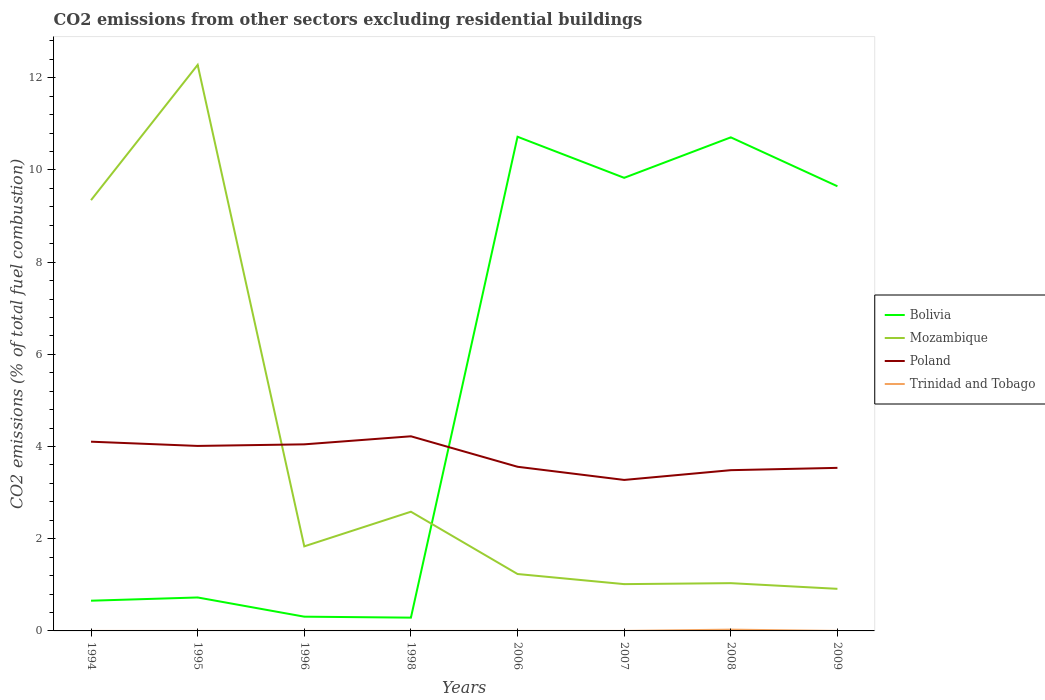How many different coloured lines are there?
Provide a succinct answer. 4. Does the line corresponding to Trinidad and Tobago intersect with the line corresponding to Poland?
Keep it short and to the point. No. Is the number of lines equal to the number of legend labels?
Keep it short and to the point. No. Across all years, what is the maximum total CO2 emitted in Poland?
Give a very brief answer. 3.28. What is the total total CO2 emitted in Poland in the graph?
Provide a succinct answer. 0.51. What is the difference between the highest and the second highest total CO2 emitted in Poland?
Your answer should be very brief. 0.95. What is the difference between the highest and the lowest total CO2 emitted in Bolivia?
Provide a succinct answer. 4. How many lines are there?
Your answer should be compact. 4. How many years are there in the graph?
Keep it short and to the point. 8. Are the values on the major ticks of Y-axis written in scientific E-notation?
Provide a short and direct response. No. Does the graph contain any zero values?
Provide a succinct answer. Yes. Where does the legend appear in the graph?
Make the answer very short. Center right. How many legend labels are there?
Offer a terse response. 4. What is the title of the graph?
Ensure brevity in your answer.  CO2 emissions from other sectors excluding residential buildings. Does "Peru" appear as one of the legend labels in the graph?
Offer a terse response. No. What is the label or title of the Y-axis?
Offer a terse response. CO2 emissions (% of total fuel combustion). What is the CO2 emissions (% of total fuel combustion) in Bolivia in 1994?
Your answer should be very brief. 0.66. What is the CO2 emissions (% of total fuel combustion) of Mozambique in 1994?
Your answer should be very brief. 9.35. What is the CO2 emissions (% of total fuel combustion) in Poland in 1994?
Your answer should be very brief. 4.11. What is the CO2 emissions (% of total fuel combustion) in Trinidad and Tobago in 1994?
Keep it short and to the point. 0. What is the CO2 emissions (% of total fuel combustion) in Bolivia in 1995?
Offer a terse response. 0.73. What is the CO2 emissions (% of total fuel combustion) of Mozambique in 1995?
Give a very brief answer. 12.28. What is the CO2 emissions (% of total fuel combustion) in Poland in 1995?
Offer a very short reply. 4.01. What is the CO2 emissions (% of total fuel combustion) in Trinidad and Tobago in 1995?
Provide a succinct answer. 0. What is the CO2 emissions (% of total fuel combustion) in Bolivia in 1996?
Your answer should be compact. 0.31. What is the CO2 emissions (% of total fuel combustion) of Mozambique in 1996?
Give a very brief answer. 1.83. What is the CO2 emissions (% of total fuel combustion) of Poland in 1996?
Keep it short and to the point. 4.05. What is the CO2 emissions (% of total fuel combustion) of Bolivia in 1998?
Make the answer very short. 0.29. What is the CO2 emissions (% of total fuel combustion) of Mozambique in 1998?
Offer a very short reply. 2.59. What is the CO2 emissions (% of total fuel combustion) of Poland in 1998?
Provide a short and direct response. 4.22. What is the CO2 emissions (% of total fuel combustion) of Bolivia in 2006?
Provide a short and direct response. 10.72. What is the CO2 emissions (% of total fuel combustion) of Mozambique in 2006?
Offer a terse response. 1.23. What is the CO2 emissions (% of total fuel combustion) of Poland in 2006?
Keep it short and to the point. 3.56. What is the CO2 emissions (% of total fuel combustion) in Trinidad and Tobago in 2006?
Keep it short and to the point. 5.05750284541343e-17. What is the CO2 emissions (% of total fuel combustion) of Bolivia in 2007?
Your answer should be compact. 9.83. What is the CO2 emissions (% of total fuel combustion) in Mozambique in 2007?
Offer a very short reply. 1.02. What is the CO2 emissions (% of total fuel combustion) in Poland in 2007?
Offer a terse response. 3.28. What is the CO2 emissions (% of total fuel combustion) in Trinidad and Tobago in 2007?
Offer a very short reply. 4.75396951487204e-17. What is the CO2 emissions (% of total fuel combustion) of Bolivia in 2008?
Provide a succinct answer. 10.71. What is the CO2 emissions (% of total fuel combustion) of Mozambique in 2008?
Your answer should be very brief. 1.04. What is the CO2 emissions (% of total fuel combustion) of Poland in 2008?
Your answer should be compact. 3.49. What is the CO2 emissions (% of total fuel combustion) of Trinidad and Tobago in 2008?
Your answer should be very brief. 0.03. What is the CO2 emissions (% of total fuel combustion) in Bolivia in 2009?
Offer a very short reply. 9.65. What is the CO2 emissions (% of total fuel combustion) of Mozambique in 2009?
Ensure brevity in your answer.  0.91. What is the CO2 emissions (% of total fuel combustion) of Poland in 2009?
Make the answer very short. 3.54. Across all years, what is the maximum CO2 emissions (% of total fuel combustion) in Bolivia?
Provide a succinct answer. 10.72. Across all years, what is the maximum CO2 emissions (% of total fuel combustion) in Mozambique?
Keep it short and to the point. 12.28. Across all years, what is the maximum CO2 emissions (% of total fuel combustion) in Poland?
Give a very brief answer. 4.22. Across all years, what is the maximum CO2 emissions (% of total fuel combustion) in Trinidad and Tobago?
Make the answer very short. 0.03. Across all years, what is the minimum CO2 emissions (% of total fuel combustion) of Bolivia?
Your answer should be compact. 0.29. Across all years, what is the minimum CO2 emissions (% of total fuel combustion) in Mozambique?
Provide a succinct answer. 0.91. Across all years, what is the minimum CO2 emissions (% of total fuel combustion) in Poland?
Your answer should be very brief. 3.28. Across all years, what is the minimum CO2 emissions (% of total fuel combustion) of Trinidad and Tobago?
Your response must be concise. 0. What is the total CO2 emissions (% of total fuel combustion) of Bolivia in the graph?
Your answer should be compact. 42.89. What is the total CO2 emissions (% of total fuel combustion) in Mozambique in the graph?
Ensure brevity in your answer.  30.25. What is the total CO2 emissions (% of total fuel combustion) in Poland in the graph?
Make the answer very short. 30.25. What is the total CO2 emissions (% of total fuel combustion) of Trinidad and Tobago in the graph?
Keep it short and to the point. 0.03. What is the difference between the CO2 emissions (% of total fuel combustion) of Bolivia in 1994 and that in 1995?
Your response must be concise. -0.07. What is the difference between the CO2 emissions (% of total fuel combustion) in Mozambique in 1994 and that in 1995?
Your answer should be very brief. -2.93. What is the difference between the CO2 emissions (% of total fuel combustion) of Poland in 1994 and that in 1995?
Offer a terse response. 0.09. What is the difference between the CO2 emissions (% of total fuel combustion) of Bolivia in 1994 and that in 1996?
Ensure brevity in your answer.  0.35. What is the difference between the CO2 emissions (% of total fuel combustion) in Mozambique in 1994 and that in 1996?
Keep it short and to the point. 7.51. What is the difference between the CO2 emissions (% of total fuel combustion) in Poland in 1994 and that in 1996?
Provide a short and direct response. 0.06. What is the difference between the CO2 emissions (% of total fuel combustion) in Bolivia in 1994 and that in 1998?
Make the answer very short. 0.37. What is the difference between the CO2 emissions (% of total fuel combustion) in Mozambique in 1994 and that in 1998?
Make the answer very short. 6.76. What is the difference between the CO2 emissions (% of total fuel combustion) in Poland in 1994 and that in 1998?
Offer a very short reply. -0.12. What is the difference between the CO2 emissions (% of total fuel combustion) in Bolivia in 1994 and that in 2006?
Ensure brevity in your answer.  -10.07. What is the difference between the CO2 emissions (% of total fuel combustion) of Mozambique in 1994 and that in 2006?
Your response must be concise. 8.11. What is the difference between the CO2 emissions (% of total fuel combustion) of Poland in 1994 and that in 2006?
Provide a short and direct response. 0.54. What is the difference between the CO2 emissions (% of total fuel combustion) of Bolivia in 1994 and that in 2007?
Give a very brief answer. -9.17. What is the difference between the CO2 emissions (% of total fuel combustion) of Mozambique in 1994 and that in 2007?
Ensure brevity in your answer.  8.33. What is the difference between the CO2 emissions (% of total fuel combustion) in Poland in 1994 and that in 2007?
Provide a short and direct response. 0.83. What is the difference between the CO2 emissions (% of total fuel combustion) of Bolivia in 1994 and that in 2008?
Keep it short and to the point. -10.05. What is the difference between the CO2 emissions (% of total fuel combustion) of Mozambique in 1994 and that in 2008?
Keep it short and to the point. 8.31. What is the difference between the CO2 emissions (% of total fuel combustion) in Poland in 1994 and that in 2008?
Provide a succinct answer. 0.62. What is the difference between the CO2 emissions (% of total fuel combustion) in Bolivia in 1994 and that in 2009?
Provide a succinct answer. -8.99. What is the difference between the CO2 emissions (% of total fuel combustion) in Mozambique in 1994 and that in 2009?
Offer a terse response. 8.43. What is the difference between the CO2 emissions (% of total fuel combustion) in Poland in 1994 and that in 2009?
Your answer should be very brief. 0.57. What is the difference between the CO2 emissions (% of total fuel combustion) in Bolivia in 1995 and that in 1996?
Offer a very short reply. 0.42. What is the difference between the CO2 emissions (% of total fuel combustion) in Mozambique in 1995 and that in 1996?
Keep it short and to the point. 10.45. What is the difference between the CO2 emissions (% of total fuel combustion) of Poland in 1995 and that in 1996?
Keep it short and to the point. -0.03. What is the difference between the CO2 emissions (% of total fuel combustion) in Bolivia in 1995 and that in 1998?
Offer a very short reply. 0.44. What is the difference between the CO2 emissions (% of total fuel combustion) of Mozambique in 1995 and that in 1998?
Give a very brief answer. 9.69. What is the difference between the CO2 emissions (% of total fuel combustion) in Poland in 1995 and that in 1998?
Keep it short and to the point. -0.21. What is the difference between the CO2 emissions (% of total fuel combustion) in Bolivia in 1995 and that in 2006?
Provide a short and direct response. -10. What is the difference between the CO2 emissions (% of total fuel combustion) in Mozambique in 1995 and that in 2006?
Ensure brevity in your answer.  11.05. What is the difference between the CO2 emissions (% of total fuel combustion) of Poland in 1995 and that in 2006?
Offer a terse response. 0.45. What is the difference between the CO2 emissions (% of total fuel combustion) of Bolivia in 1995 and that in 2007?
Your answer should be very brief. -9.1. What is the difference between the CO2 emissions (% of total fuel combustion) of Mozambique in 1995 and that in 2007?
Keep it short and to the point. 11.27. What is the difference between the CO2 emissions (% of total fuel combustion) in Poland in 1995 and that in 2007?
Your answer should be compact. 0.74. What is the difference between the CO2 emissions (% of total fuel combustion) in Bolivia in 1995 and that in 2008?
Your answer should be compact. -9.98. What is the difference between the CO2 emissions (% of total fuel combustion) in Mozambique in 1995 and that in 2008?
Provide a succinct answer. 11.24. What is the difference between the CO2 emissions (% of total fuel combustion) in Poland in 1995 and that in 2008?
Provide a succinct answer. 0.53. What is the difference between the CO2 emissions (% of total fuel combustion) in Bolivia in 1995 and that in 2009?
Keep it short and to the point. -8.92. What is the difference between the CO2 emissions (% of total fuel combustion) of Mozambique in 1995 and that in 2009?
Offer a terse response. 11.37. What is the difference between the CO2 emissions (% of total fuel combustion) of Poland in 1995 and that in 2009?
Keep it short and to the point. 0.48. What is the difference between the CO2 emissions (% of total fuel combustion) of Bolivia in 1996 and that in 1998?
Provide a succinct answer. 0.02. What is the difference between the CO2 emissions (% of total fuel combustion) of Mozambique in 1996 and that in 1998?
Offer a very short reply. -0.75. What is the difference between the CO2 emissions (% of total fuel combustion) of Poland in 1996 and that in 1998?
Provide a short and direct response. -0.17. What is the difference between the CO2 emissions (% of total fuel combustion) in Bolivia in 1996 and that in 2006?
Provide a short and direct response. -10.41. What is the difference between the CO2 emissions (% of total fuel combustion) of Mozambique in 1996 and that in 2006?
Provide a succinct answer. 0.6. What is the difference between the CO2 emissions (% of total fuel combustion) of Poland in 1996 and that in 2006?
Your answer should be compact. 0.49. What is the difference between the CO2 emissions (% of total fuel combustion) in Bolivia in 1996 and that in 2007?
Ensure brevity in your answer.  -9.52. What is the difference between the CO2 emissions (% of total fuel combustion) in Mozambique in 1996 and that in 2007?
Provide a short and direct response. 0.82. What is the difference between the CO2 emissions (% of total fuel combustion) of Poland in 1996 and that in 2007?
Make the answer very short. 0.77. What is the difference between the CO2 emissions (% of total fuel combustion) in Bolivia in 1996 and that in 2008?
Provide a succinct answer. -10.4. What is the difference between the CO2 emissions (% of total fuel combustion) of Mozambique in 1996 and that in 2008?
Your answer should be very brief. 0.8. What is the difference between the CO2 emissions (% of total fuel combustion) in Poland in 1996 and that in 2008?
Provide a succinct answer. 0.56. What is the difference between the CO2 emissions (% of total fuel combustion) in Bolivia in 1996 and that in 2009?
Keep it short and to the point. -9.34. What is the difference between the CO2 emissions (% of total fuel combustion) of Mozambique in 1996 and that in 2009?
Your response must be concise. 0.92. What is the difference between the CO2 emissions (% of total fuel combustion) in Poland in 1996 and that in 2009?
Your answer should be very brief. 0.51. What is the difference between the CO2 emissions (% of total fuel combustion) of Bolivia in 1998 and that in 2006?
Offer a terse response. -10.43. What is the difference between the CO2 emissions (% of total fuel combustion) of Mozambique in 1998 and that in 2006?
Make the answer very short. 1.35. What is the difference between the CO2 emissions (% of total fuel combustion) of Poland in 1998 and that in 2006?
Offer a very short reply. 0.66. What is the difference between the CO2 emissions (% of total fuel combustion) in Bolivia in 1998 and that in 2007?
Offer a very short reply. -9.54. What is the difference between the CO2 emissions (% of total fuel combustion) of Mozambique in 1998 and that in 2007?
Your answer should be very brief. 1.57. What is the difference between the CO2 emissions (% of total fuel combustion) in Poland in 1998 and that in 2007?
Provide a short and direct response. 0.95. What is the difference between the CO2 emissions (% of total fuel combustion) in Bolivia in 1998 and that in 2008?
Make the answer very short. -10.42. What is the difference between the CO2 emissions (% of total fuel combustion) of Mozambique in 1998 and that in 2008?
Your response must be concise. 1.55. What is the difference between the CO2 emissions (% of total fuel combustion) in Poland in 1998 and that in 2008?
Ensure brevity in your answer.  0.73. What is the difference between the CO2 emissions (% of total fuel combustion) in Bolivia in 1998 and that in 2009?
Provide a succinct answer. -9.36. What is the difference between the CO2 emissions (% of total fuel combustion) in Mozambique in 1998 and that in 2009?
Your answer should be very brief. 1.67. What is the difference between the CO2 emissions (% of total fuel combustion) in Poland in 1998 and that in 2009?
Provide a short and direct response. 0.69. What is the difference between the CO2 emissions (% of total fuel combustion) of Bolivia in 2006 and that in 2007?
Provide a succinct answer. 0.89. What is the difference between the CO2 emissions (% of total fuel combustion) of Mozambique in 2006 and that in 2007?
Your response must be concise. 0.22. What is the difference between the CO2 emissions (% of total fuel combustion) in Poland in 2006 and that in 2007?
Your answer should be compact. 0.29. What is the difference between the CO2 emissions (% of total fuel combustion) in Trinidad and Tobago in 2006 and that in 2007?
Keep it short and to the point. 0. What is the difference between the CO2 emissions (% of total fuel combustion) of Bolivia in 2006 and that in 2008?
Your response must be concise. 0.01. What is the difference between the CO2 emissions (% of total fuel combustion) of Mozambique in 2006 and that in 2008?
Provide a short and direct response. 0.2. What is the difference between the CO2 emissions (% of total fuel combustion) of Poland in 2006 and that in 2008?
Your answer should be compact. 0.07. What is the difference between the CO2 emissions (% of total fuel combustion) in Trinidad and Tobago in 2006 and that in 2008?
Your answer should be very brief. -0.03. What is the difference between the CO2 emissions (% of total fuel combustion) in Bolivia in 2006 and that in 2009?
Your response must be concise. 1.07. What is the difference between the CO2 emissions (% of total fuel combustion) in Mozambique in 2006 and that in 2009?
Provide a short and direct response. 0.32. What is the difference between the CO2 emissions (% of total fuel combustion) of Poland in 2006 and that in 2009?
Your answer should be compact. 0.02. What is the difference between the CO2 emissions (% of total fuel combustion) in Bolivia in 2007 and that in 2008?
Keep it short and to the point. -0.88. What is the difference between the CO2 emissions (% of total fuel combustion) in Mozambique in 2007 and that in 2008?
Offer a very short reply. -0.02. What is the difference between the CO2 emissions (% of total fuel combustion) of Poland in 2007 and that in 2008?
Offer a terse response. -0.21. What is the difference between the CO2 emissions (% of total fuel combustion) in Trinidad and Tobago in 2007 and that in 2008?
Make the answer very short. -0.03. What is the difference between the CO2 emissions (% of total fuel combustion) of Bolivia in 2007 and that in 2009?
Offer a very short reply. 0.18. What is the difference between the CO2 emissions (% of total fuel combustion) in Mozambique in 2007 and that in 2009?
Give a very brief answer. 0.1. What is the difference between the CO2 emissions (% of total fuel combustion) of Poland in 2007 and that in 2009?
Provide a succinct answer. -0.26. What is the difference between the CO2 emissions (% of total fuel combustion) in Bolivia in 2008 and that in 2009?
Provide a succinct answer. 1.06. What is the difference between the CO2 emissions (% of total fuel combustion) in Mozambique in 2008 and that in 2009?
Offer a terse response. 0.12. What is the difference between the CO2 emissions (% of total fuel combustion) in Bolivia in 1994 and the CO2 emissions (% of total fuel combustion) in Mozambique in 1995?
Offer a very short reply. -11.62. What is the difference between the CO2 emissions (% of total fuel combustion) of Bolivia in 1994 and the CO2 emissions (% of total fuel combustion) of Poland in 1995?
Your answer should be compact. -3.36. What is the difference between the CO2 emissions (% of total fuel combustion) of Mozambique in 1994 and the CO2 emissions (% of total fuel combustion) of Poland in 1995?
Provide a succinct answer. 5.33. What is the difference between the CO2 emissions (% of total fuel combustion) in Bolivia in 1994 and the CO2 emissions (% of total fuel combustion) in Mozambique in 1996?
Ensure brevity in your answer.  -1.18. What is the difference between the CO2 emissions (% of total fuel combustion) in Bolivia in 1994 and the CO2 emissions (% of total fuel combustion) in Poland in 1996?
Keep it short and to the point. -3.39. What is the difference between the CO2 emissions (% of total fuel combustion) in Mozambique in 1994 and the CO2 emissions (% of total fuel combustion) in Poland in 1996?
Offer a very short reply. 5.3. What is the difference between the CO2 emissions (% of total fuel combustion) of Bolivia in 1994 and the CO2 emissions (% of total fuel combustion) of Mozambique in 1998?
Ensure brevity in your answer.  -1.93. What is the difference between the CO2 emissions (% of total fuel combustion) in Bolivia in 1994 and the CO2 emissions (% of total fuel combustion) in Poland in 1998?
Make the answer very short. -3.57. What is the difference between the CO2 emissions (% of total fuel combustion) in Mozambique in 1994 and the CO2 emissions (% of total fuel combustion) in Poland in 1998?
Your answer should be compact. 5.12. What is the difference between the CO2 emissions (% of total fuel combustion) of Bolivia in 1994 and the CO2 emissions (% of total fuel combustion) of Mozambique in 2006?
Offer a very short reply. -0.58. What is the difference between the CO2 emissions (% of total fuel combustion) in Bolivia in 1994 and the CO2 emissions (% of total fuel combustion) in Poland in 2006?
Provide a short and direct response. -2.91. What is the difference between the CO2 emissions (% of total fuel combustion) of Bolivia in 1994 and the CO2 emissions (% of total fuel combustion) of Trinidad and Tobago in 2006?
Offer a very short reply. 0.66. What is the difference between the CO2 emissions (% of total fuel combustion) of Mozambique in 1994 and the CO2 emissions (% of total fuel combustion) of Poland in 2006?
Provide a short and direct response. 5.78. What is the difference between the CO2 emissions (% of total fuel combustion) of Mozambique in 1994 and the CO2 emissions (% of total fuel combustion) of Trinidad and Tobago in 2006?
Ensure brevity in your answer.  9.35. What is the difference between the CO2 emissions (% of total fuel combustion) in Poland in 1994 and the CO2 emissions (% of total fuel combustion) in Trinidad and Tobago in 2006?
Your answer should be compact. 4.11. What is the difference between the CO2 emissions (% of total fuel combustion) in Bolivia in 1994 and the CO2 emissions (% of total fuel combustion) in Mozambique in 2007?
Your response must be concise. -0.36. What is the difference between the CO2 emissions (% of total fuel combustion) in Bolivia in 1994 and the CO2 emissions (% of total fuel combustion) in Poland in 2007?
Provide a short and direct response. -2.62. What is the difference between the CO2 emissions (% of total fuel combustion) of Bolivia in 1994 and the CO2 emissions (% of total fuel combustion) of Trinidad and Tobago in 2007?
Make the answer very short. 0.66. What is the difference between the CO2 emissions (% of total fuel combustion) in Mozambique in 1994 and the CO2 emissions (% of total fuel combustion) in Poland in 2007?
Your answer should be compact. 6.07. What is the difference between the CO2 emissions (% of total fuel combustion) of Mozambique in 1994 and the CO2 emissions (% of total fuel combustion) of Trinidad and Tobago in 2007?
Give a very brief answer. 9.35. What is the difference between the CO2 emissions (% of total fuel combustion) in Poland in 1994 and the CO2 emissions (% of total fuel combustion) in Trinidad and Tobago in 2007?
Keep it short and to the point. 4.11. What is the difference between the CO2 emissions (% of total fuel combustion) in Bolivia in 1994 and the CO2 emissions (% of total fuel combustion) in Mozambique in 2008?
Ensure brevity in your answer.  -0.38. What is the difference between the CO2 emissions (% of total fuel combustion) in Bolivia in 1994 and the CO2 emissions (% of total fuel combustion) in Poland in 2008?
Ensure brevity in your answer.  -2.83. What is the difference between the CO2 emissions (% of total fuel combustion) in Bolivia in 1994 and the CO2 emissions (% of total fuel combustion) in Trinidad and Tobago in 2008?
Provide a succinct answer. 0.63. What is the difference between the CO2 emissions (% of total fuel combustion) in Mozambique in 1994 and the CO2 emissions (% of total fuel combustion) in Poland in 2008?
Offer a very short reply. 5.86. What is the difference between the CO2 emissions (% of total fuel combustion) of Mozambique in 1994 and the CO2 emissions (% of total fuel combustion) of Trinidad and Tobago in 2008?
Give a very brief answer. 9.32. What is the difference between the CO2 emissions (% of total fuel combustion) of Poland in 1994 and the CO2 emissions (% of total fuel combustion) of Trinidad and Tobago in 2008?
Your answer should be very brief. 4.08. What is the difference between the CO2 emissions (% of total fuel combustion) of Bolivia in 1994 and the CO2 emissions (% of total fuel combustion) of Mozambique in 2009?
Make the answer very short. -0.26. What is the difference between the CO2 emissions (% of total fuel combustion) of Bolivia in 1994 and the CO2 emissions (% of total fuel combustion) of Poland in 2009?
Your answer should be very brief. -2.88. What is the difference between the CO2 emissions (% of total fuel combustion) of Mozambique in 1994 and the CO2 emissions (% of total fuel combustion) of Poland in 2009?
Make the answer very short. 5.81. What is the difference between the CO2 emissions (% of total fuel combustion) of Bolivia in 1995 and the CO2 emissions (% of total fuel combustion) of Mozambique in 1996?
Your answer should be very brief. -1.11. What is the difference between the CO2 emissions (% of total fuel combustion) of Bolivia in 1995 and the CO2 emissions (% of total fuel combustion) of Poland in 1996?
Your response must be concise. -3.32. What is the difference between the CO2 emissions (% of total fuel combustion) of Mozambique in 1995 and the CO2 emissions (% of total fuel combustion) of Poland in 1996?
Offer a very short reply. 8.23. What is the difference between the CO2 emissions (% of total fuel combustion) of Bolivia in 1995 and the CO2 emissions (% of total fuel combustion) of Mozambique in 1998?
Give a very brief answer. -1.86. What is the difference between the CO2 emissions (% of total fuel combustion) of Bolivia in 1995 and the CO2 emissions (% of total fuel combustion) of Poland in 1998?
Provide a short and direct response. -3.5. What is the difference between the CO2 emissions (% of total fuel combustion) of Mozambique in 1995 and the CO2 emissions (% of total fuel combustion) of Poland in 1998?
Offer a terse response. 8.06. What is the difference between the CO2 emissions (% of total fuel combustion) in Bolivia in 1995 and the CO2 emissions (% of total fuel combustion) in Mozambique in 2006?
Offer a terse response. -0.51. What is the difference between the CO2 emissions (% of total fuel combustion) of Bolivia in 1995 and the CO2 emissions (% of total fuel combustion) of Poland in 2006?
Give a very brief answer. -2.84. What is the difference between the CO2 emissions (% of total fuel combustion) in Bolivia in 1995 and the CO2 emissions (% of total fuel combustion) in Trinidad and Tobago in 2006?
Your answer should be very brief. 0.73. What is the difference between the CO2 emissions (% of total fuel combustion) of Mozambique in 1995 and the CO2 emissions (% of total fuel combustion) of Poland in 2006?
Your answer should be compact. 8.72. What is the difference between the CO2 emissions (% of total fuel combustion) of Mozambique in 1995 and the CO2 emissions (% of total fuel combustion) of Trinidad and Tobago in 2006?
Your answer should be compact. 12.28. What is the difference between the CO2 emissions (% of total fuel combustion) in Poland in 1995 and the CO2 emissions (% of total fuel combustion) in Trinidad and Tobago in 2006?
Offer a terse response. 4.01. What is the difference between the CO2 emissions (% of total fuel combustion) in Bolivia in 1995 and the CO2 emissions (% of total fuel combustion) in Mozambique in 2007?
Provide a short and direct response. -0.29. What is the difference between the CO2 emissions (% of total fuel combustion) in Bolivia in 1995 and the CO2 emissions (% of total fuel combustion) in Poland in 2007?
Offer a very short reply. -2.55. What is the difference between the CO2 emissions (% of total fuel combustion) of Bolivia in 1995 and the CO2 emissions (% of total fuel combustion) of Trinidad and Tobago in 2007?
Make the answer very short. 0.73. What is the difference between the CO2 emissions (% of total fuel combustion) in Mozambique in 1995 and the CO2 emissions (% of total fuel combustion) in Poland in 2007?
Offer a terse response. 9.01. What is the difference between the CO2 emissions (% of total fuel combustion) of Mozambique in 1995 and the CO2 emissions (% of total fuel combustion) of Trinidad and Tobago in 2007?
Offer a very short reply. 12.28. What is the difference between the CO2 emissions (% of total fuel combustion) in Poland in 1995 and the CO2 emissions (% of total fuel combustion) in Trinidad and Tobago in 2007?
Ensure brevity in your answer.  4.01. What is the difference between the CO2 emissions (% of total fuel combustion) of Bolivia in 1995 and the CO2 emissions (% of total fuel combustion) of Mozambique in 2008?
Give a very brief answer. -0.31. What is the difference between the CO2 emissions (% of total fuel combustion) of Bolivia in 1995 and the CO2 emissions (% of total fuel combustion) of Poland in 2008?
Your answer should be compact. -2.76. What is the difference between the CO2 emissions (% of total fuel combustion) in Bolivia in 1995 and the CO2 emissions (% of total fuel combustion) in Trinidad and Tobago in 2008?
Provide a succinct answer. 0.7. What is the difference between the CO2 emissions (% of total fuel combustion) in Mozambique in 1995 and the CO2 emissions (% of total fuel combustion) in Poland in 2008?
Keep it short and to the point. 8.79. What is the difference between the CO2 emissions (% of total fuel combustion) of Mozambique in 1995 and the CO2 emissions (% of total fuel combustion) of Trinidad and Tobago in 2008?
Make the answer very short. 12.25. What is the difference between the CO2 emissions (% of total fuel combustion) in Poland in 1995 and the CO2 emissions (% of total fuel combustion) in Trinidad and Tobago in 2008?
Give a very brief answer. 3.99. What is the difference between the CO2 emissions (% of total fuel combustion) in Bolivia in 1995 and the CO2 emissions (% of total fuel combustion) in Mozambique in 2009?
Keep it short and to the point. -0.19. What is the difference between the CO2 emissions (% of total fuel combustion) of Bolivia in 1995 and the CO2 emissions (% of total fuel combustion) of Poland in 2009?
Provide a short and direct response. -2.81. What is the difference between the CO2 emissions (% of total fuel combustion) in Mozambique in 1995 and the CO2 emissions (% of total fuel combustion) in Poland in 2009?
Provide a succinct answer. 8.74. What is the difference between the CO2 emissions (% of total fuel combustion) of Bolivia in 1996 and the CO2 emissions (% of total fuel combustion) of Mozambique in 1998?
Make the answer very short. -2.28. What is the difference between the CO2 emissions (% of total fuel combustion) in Bolivia in 1996 and the CO2 emissions (% of total fuel combustion) in Poland in 1998?
Provide a succinct answer. -3.91. What is the difference between the CO2 emissions (% of total fuel combustion) of Mozambique in 1996 and the CO2 emissions (% of total fuel combustion) of Poland in 1998?
Offer a very short reply. -2.39. What is the difference between the CO2 emissions (% of total fuel combustion) in Bolivia in 1996 and the CO2 emissions (% of total fuel combustion) in Mozambique in 2006?
Ensure brevity in your answer.  -0.93. What is the difference between the CO2 emissions (% of total fuel combustion) in Bolivia in 1996 and the CO2 emissions (% of total fuel combustion) in Poland in 2006?
Provide a succinct answer. -3.25. What is the difference between the CO2 emissions (% of total fuel combustion) of Bolivia in 1996 and the CO2 emissions (% of total fuel combustion) of Trinidad and Tobago in 2006?
Give a very brief answer. 0.31. What is the difference between the CO2 emissions (% of total fuel combustion) of Mozambique in 1996 and the CO2 emissions (% of total fuel combustion) of Poland in 2006?
Ensure brevity in your answer.  -1.73. What is the difference between the CO2 emissions (% of total fuel combustion) of Mozambique in 1996 and the CO2 emissions (% of total fuel combustion) of Trinidad and Tobago in 2006?
Make the answer very short. 1.83. What is the difference between the CO2 emissions (% of total fuel combustion) of Poland in 1996 and the CO2 emissions (% of total fuel combustion) of Trinidad and Tobago in 2006?
Ensure brevity in your answer.  4.05. What is the difference between the CO2 emissions (% of total fuel combustion) of Bolivia in 1996 and the CO2 emissions (% of total fuel combustion) of Mozambique in 2007?
Provide a succinct answer. -0.71. What is the difference between the CO2 emissions (% of total fuel combustion) of Bolivia in 1996 and the CO2 emissions (% of total fuel combustion) of Poland in 2007?
Your answer should be very brief. -2.97. What is the difference between the CO2 emissions (% of total fuel combustion) in Bolivia in 1996 and the CO2 emissions (% of total fuel combustion) in Trinidad and Tobago in 2007?
Offer a terse response. 0.31. What is the difference between the CO2 emissions (% of total fuel combustion) of Mozambique in 1996 and the CO2 emissions (% of total fuel combustion) of Poland in 2007?
Your answer should be very brief. -1.44. What is the difference between the CO2 emissions (% of total fuel combustion) in Mozambique in 1996 and the CO2 emissions (% of total fuel combustion) in Trinidad and Tobago in 2007?
Your answer should be very brief. 1.83. What is the difference between the CO2 emissions (% of total fuel combustion) in Poland in 1996 and the CO2 emissions (% of total fuel combustion) in Trinidad and Tobago in 2007?
Offer a terse response. 4.05. What is the difference between the CO2 emissions (% of total fuel combustion) of Bolivia in 1996 and the CO2 emissions (% of total fuel combustion) of Mozambique in 2008?
Give a very brief answer. -0.73. What is the difference between the CO2 emissions (% of total fuel combustion) of Bolivia in 1996 and the CO2 emissions (% of total fuel combustion) of Poland in 2008?
Offer a terse response. -3.18. What is the difference between the CO2 emissions (% of total fuel combustion) in Bolivia in 1996 and the CO2 emissions (% of total fuel combustion) in Trinidad and Tobago in 2008?
Offer a terse response. 0.28. What is the difference between the CO2 emissions (% of total fuel combustion) of Mozambique in 1996 and the CO2 emissions (% of total fuel combustion) of Poland in 2008?
Your response must be concise. -1.65. What is the difference between the CO2 emissions (% of total fuel combustion) in Mozambique in 1996 and the CO2 emissions (% of total fuel combustion) in Trinidad and Tobago in 2008?
Ensure brevity in your answer.  1.81. What is the difference between the CO2 emissions (% of total fuel combustion) of Poland in 1996 and the CO2 emissions (% of total fuel combustion) of Trinidad and Tobago in 2008?
Your answer should be very brief. 4.02. What is the difference between the CO2 emissions (% of total fuel combustion) in Bolivia in 1996 and the CO2 emissions (% of total fuel combustion) in Mozambique in 2009?
Make the answer very short. -0.6. What is the difference between the CO2 emissions (% of total fuel combustion) of Bolivia in 1996 and the CO2 emissions (% of total fuel combustion) of Poland in 2009?
Your answer should be compact. -3.23. What is the difference between the CO2 emissions (% of total fuel combustion) in Mozambique in 1996 and the CO2 emissions (% of total fuel combustion) in Poland in 2009?
Provide a short and direct response. -1.7. What is the difference between the CO2 emissions (% of total fuel combustion) of Bolivia in 1998 and the CO2 emissions (% of total fuel combustion) of Mozambique in 2006?
Your response must be concise. -0.95. What is the difference between the CO2 emissions (% of total fuel combustion) of Bolivia in 1998 and the CO2 emissions (% of total fuel combustion) of Poland in 2006?
Provide a succinct answer. -3.27. What is the difference between the CO2 emissions (% of total fuel combustion) of Bolivia in 1998 and the CO2 emissions (% of total fuel combustion) of Trinidad and Tobago in 2006?
Your answer should be compact. 0.29. What is the difference between the CO2 emissions (% of total fuel combustion) of Mozambique in 1998 and the CO2 emissions (% of total fuel combustion) of Poland in 2006?
Give a very brief answer. -0.98. What is the difference between the CO2 emissions (% of total fuel combustion) in Mozambique in 1998 and the CO2 emissions (% of total fuel combustion) in Trinidad and Tobago in 2006?
Offer a very short reply. 2.59. What is the difference between the CO2 emissions (% of total fuel combustion) of Poland in 1998 and the CO2 emissions (% of total fuel combustion) of Trinidad and Tobago in 2006?
Ensure brevity in your answer.  4.22. What is the difference between the CO2 emissions (% of total fuel combustion) of Bolivia in 1998 and the CO2 emissions (% of total fuel combustion) of Mozambique in 2007?
Your answer should be very brief. -0.73. What is the difference between the CO2 emissions (% of total fuel combustion) of Bolivia in 1998 and the CO2 emissions (% of total fuel combustion) of Poland in 2007?
Provide a short and direct response. -2.99. What is the difference between the CO2 emissions (% of total fuel combustion) in Bolivia in 1998 and the CO2 emissions (% of total fuel combustion) in Trinidad and Tobago in 2007?
Keep it short and to the point. 0.29. What is the difference between the CO2 emissions (% of total fuel combustion) of Mozambique in 1998 and the CO2 emissions (% of total fuel combustion) of Poland in 2007?
Your answer should be compact. -0.69. What is the difference between the CO2 emissions (% of total fuel combustion) of Mozambique in 1998 and the CO2 emissions (% of total fuel combustion) of Trinidad and Tobago in 2007?
Provide a succinct answer. 2.59. What is the difference between the CO2 emissions (% of total fuel combustion) in Poland in 1998 and the CO2 emissions (% of total fuel combustion) in Trinidad and Tobago in 2007?
Offer a very short reply. 4.22. What is the difference between the CO2 emissions (% of total fuel combustion) of Bolivia in 1998 and the CO2 emissions (% of total fuel combustion) of Mozambique in 2008?
Your answer should be compact. -0.75. What is the difference between the CO2 emissions (% of total fuel combustion) in Bolivia in 1998 and the CO2 emissions (% of total fuel combustion) in Poland in 2008?
Offer a terse response. -3.2. What is the difference between the CO2 emissions (% of total fuel combustion) of Bolivia in 1998 and the CO2 emissions (% of total fuel combustion) of Trinidad and Tobago in 2008?
Provide a short and direct response. 0.26. What is the difference between the CO2 emissions (% of total fuel combustion) in Mozambique in 1998 and the CO2 emissions (% of total fuel combustion) in Poland in 2008?
Provide a short and direct response. -0.9. What is the difference between the CO2 emissions (% of total fuel combustion) of Mozambique in 1998 and the CO2 emissions (% of total fuel combustion) of Trinidad and Tobago in 2008?
Your answer should be very brief. 2.56. What is the difference between the CO2 emissions (% of total fuel combustion) of Poland in 1998 and the CO2 emissions (% of total fuel combustion) of Trinidad and Tobago in 2008?
Offer a terse response. 4.19. What is the difference between the CO2 emissions (% of total fuel combustion) in Bolivia in 1998 and the CO2 emissions (% of total fuel combustion) in Mozambique in 2009?
Make the answer very short. -0.63. What is the difference between the CO2 emissions (% of total fuel combustion) of Bolivia in 1998 and the CO2 emissions (% of total fuel combustion) of Poland in 2009?
Offer a very short reply. -3.25. What is the difference between the CO2 emissions (% of total fuel combustion) of Mozambique in 1998 and the CO2 emissions (% of total fuel combustion) of Poland in 2009?
Your response must be concise. -0.95. What is the difference between the CO2 emissions (% of total fuel combustion) in Bolivia in 2006 and the CO2 emissions (% of total fuel combustion) in Mozambique in 2007?
Offer a very short reply. 9.71. What is the difference between the CO2 emissions (% of total fuel combustion) of Bolivia in 2006 and the CO2 emissions (% of total fuel combustion) of Poland in 2007?
Provide a short and direct response. 7.45. What is the difference between the CO2 emissions (% of total fuel combustion) in Bolivia in 2006 and the CO2 emissions (% of total fuel combustion) in Trinidad and Tobago in 2007?
Provide a succinct answer. 10.72. What is the difference between the CO2 emissions (% of total fuel combustion) of Mozambique in 2006 and the CO2 emissions (% of total fuel combustion) of Poland in 2007?
Offer a terse response. -2.04. What is the difference between the CO2 emissions (% of total fuel combustion) of Mozambique in 2006 and the CO2 emissions (% of total fuel combustion) of Trinidad and Tobago in 2007?
Offer a terse response. 1.23. What is the difference between the CO2 emissions (% of total fuel combustion) in Poland in 2006 and the CO2 emissions (% of total fuel combustion) in Trinidad and Tobago in 2007?
Offer a very short reply. 3.56. What is the difference between the CO2 emissions (% of total fuel combustion) of Bolivia in 2006 and the CO2 emissions (% of total fuel combustion) of Mozambique in 2008?
Your answer should be very brief. 9.69. What is the difference between the CO2 emissions (% of total fuel combustion) in Bolivia in 2006 and the CO2 emissions (% of total fuel combustion) in Poland in 2008?
Your answer should be compact. 7.23. What is the difference between the CO2 emissions (% of total fuel combustion) in Bolivia in 2006 and the CO2 emissions (% of total fuel combustion) in Trinidad and Tobago in 2008?
Your response must be concise. 10.69. What is the difference between the CO2 emissions (% of total fuel combustion) of Mozambique in 2006 and the CO2 emissions (% of total fuel combustion) of Poland in 2008?
Provide a short and direct response. -2.25. What is the difference between the CO2 emissions (% of total fuel combustion) in Mozambique in 2006 and the CO2 emissions (% of total fuel combustion) in Trinidad and Tobago in 2008?
Offer a terse response. 1.21. What is the difference between the CO2 emissions (% of total fuel combustion) in Poland in 2006 and the CO2 emissions (% of total fuel combustion) in Trinidad and Tobago in 2008?
Keep it short and to the point. 3.53. What is the difference between the CO2 emissions (% of total fuel combustion) in Bolivia in 2006 and the CO2 emissions (% of total fuel combustion) in Mozambique in 2009?
Provide a succinct answer. 9.81. What is the difference between the CO2 emissions (% of total fuel combustion) of Bolivia in 2006 and the CO2 emissions (% of total fuel combustion) of Poland in 2009?
Offer a terse response. 7.18. What is the difference between the CO2 emissions (% of total fuel combustion) in Mozambique in 2006 and the CO2 emissions (% of total fuel combustion) in Poland in 2009?
Provide a succinct answer. -2.3. What is the difference between the CO2 emissions (% of total fuel combustion) of Bolivia in 2007 and the CO2 emissions (% of total fuel combustion) of Mozambique in 2008?
Offer a terse response. 8.79. What is the difference between the CO2 emissions (% of total fuel combustion) of Bolivia in 2007 and the CO2 emissions (% of total fuel combustion) of Poland in 2008?
Your response must be concise. 6.34. What is the difference between the CO2 emissions (% of total fuel combustion) in Bolivia in 2007 and the CO2 emissions (% of total fuel combustion) in Trinidad and Tobago in 2008?
Offer a very short reply. 9.8. What is the difference between the CO2 emissions (% of total fuel combustion) of Mozambique in 2007 and the CO2 emissions (% of total fuel combustion) of Poland in 2008?
Provide a succinct answer. -2.47. What is the difference between the CO2 emissions (% of total fuel combustion) of Mozambique in 2007 and the CO2 emissions (% of total fuel combustion) of Trinidad and Tobago in 2008?
Keep it short and to the point. 0.99. What is the difference between the CO2 emissions (% of total fuel combustion) in Poland in 2007 and the CO2 emissions (% of total fuel combustion) in Trinidad and Tobago in 2008?
Ensure brevity in your answer.  3.25. What is the difference between the CO2 emissions (% of total fuel combustion) in Bolivia in 2007 and the CO2 emissions (% of total fuel combustion) in Mozambique in 2009?
Your answer should be compact. 8.92. What is the difference between the CO2 emissions (% of total fuel combustion) in Bolivia in 2007 and the CO2 emissions (% of total fuel combustion) in Poland in 2009?
Your response must be concise. 6.29. What is the difference between the CO2 emissions (% of total fuel combustion) of Mozambique in 2007 and the CO2 emissions (% of total fuel combustion) of Poland in 2009?
Your answer should be compact. -2.52. What is the difference between the CO2 emissions (% of total fuel combustion) of Bolivia in 2008 and the CO2 emissions (% of total fuel combustion) of Mozambique in 2009?
Offer a terse response. 9.8. What is the difference between the CO2 emissions (% of total fuel combustion) in Bolivia in 2008 and the CO2 emissions (% of total fuel combustion) in Poland in 2009?
Your answer should be very brief. 7.17. What is the difference between the CO2 emissions (% of total fuel combustion) in Mozambique in 2008 and the CO2 emissions (% of total fuel combustion) in Poland in 2009?
Offer a terse response. -2.5. What is the average CO2 emissions (% of total fuel combustion) in Bolivia per year?
Offer a very short reply. 5.36. What is the average CO2 emissions (% of total fuel combustion) of Mozambique per year?
Your answer should be compact. 3.78. What is the average CO2 emissions (% of total fuel combustion) of Poland per year?
Offer a very short reply. 3.78. What is the average CO2 emissions (% of total fuel combustion) of Trinidad and Tobago per year?
Your answer should be very brief. 0. In the year 1994, what is the difference between the CO2 emissions (% of total fuel combustion) of Bolivia and CO2 emissions (% of total fuel combustion) of Mozambique?
Keep it short and to the point. -8.69. In the year 1994, what is the difference between the CO2 emissions (% of total fuel combustion) in Bolivia and CO2 emissions (% of total fuel combustion) in Poland?
Make the answer very short. -3.45. In the year 1994, what is the difference between the CO2 emissions (% of total fuel combustion) in Mozambique and CO2 emissions (% of total fuel combustion) in Poland?
Ensure brevity in your answer.  5.24. In the year 1995, what is the difference between the CO2 emissions (% of total fuel combustion) of Bolivia and CO2 emissions (% of total fuel combustion) of Mozambique?
Keep it short and to the point. -11.55. In the year 1995, what is the difference between the CO2 emissions (% of total fuel combustion) of Bolivia and CO2 emissions (% of total fuel combustion) of Poland?
Offer a very short reply. -3.29. In the year 1995, what is the difference between the CO2 emissions (% of total fuel combustion) in Mozambique and CO2 emissions (% of total fuel combustion) in Poland?
Ensure brevity in your answer.  8.27. In the year 1996, what is the difference between the CO2 emissions (% of total fuel combustion) of Bolivia and CO2 emissions (% of total fuel combustion) of Mozambique?
Keep it short and to the point. -1.53. In the year 1996, what is the difference between the CO2 emissions (% of total fuel combustion) of Bolivia and CO2 emissions (% of total fuel combustion) of Poland?
Offer a terse response. -3.74. In the year 1996, what is the difference between the CO2 emissions (% of total fuel combustion) in Mozambique and CO2 emissions (% of total fuel combustion) in Poland?
Offer a very short reply. -2.21. In the year 1998, what is the difference between the CO2 emissions (% of total fuel combustion) in Bolivia and CO2 emissions (% of total fuel combustion) in Mozambique?
Provide a succinct answer. -2.3. In the year 1998, what is the difference between the CO2 emissions (% of total fuel combustion) in Bolivia and CO2 emissions (% of total fuel combustion) in Poland?
Provide a short and direct response. -3.93. In the year 1998, what is the difference between the CO2 emissions (% of total fuel combustion) in Mozambique and CO2 emissions (% of total fuel combustion) in Poland?
Provide a succinct answer. -1.64. In the year 2006, what is the difference between the CO2 emissions (% of total fuel combustion) of Bolivia and CO2 emissions (% of total fuel combustion) of Mozambique?
Provide a short and direct response. 9.49. In the year 2006, what is the difference between the CO2 emissions (% of total fuel combustion) of Bolivia and CO2 emissions (% of total fuel combustion) of Poland?
Your response must be concise. 7.16. In the year 2006, what is the difference between the CO2 emissions (% of total fuel combustion) of Bolivia and CO2 emissions (% of total fuel combustion) of Trinidad and Tobago?
Your answer should be compact. 10.72. In the year 2006, what is the difference between the CO2 emissions (% of total fuel combustion) of Mozambique and CO2 emissions (% of total fuel combustion) of Poland?
Your answer should be very brief. -2.33. In the year 2006, what is the difference between the CO2 emissions (% of total fuel combustion) in Mozambique and CO2 emissions (% of total fuel combustion) in Trinidad and Tobago?
Your answer should be very brief. 1.23. In the year 2006, what is the difference between the CO2 emissions (% of total fuel combustion) in Poland and CO2 emissions (% of total fuel combustion) in Trinidad and Tobago?
Ensure brevity in your answer.  3.56. In the year 2007, what is the difference between the CO2 emissions (% of total fuel combustion) in Bolivia and CO2 emissions (% of total fuel combustion) in Mozambique?
Offer a terse response. 8.81. In the year 2007, what is the difference between the CO2 emissions (% of total fuel combustion) in Bolivia and CO2 emissions (% of total fuel combustion) in Poland?
Your response must be concise. 6.55. In the year 2007, what is the difference between the CO2 emissions (% of total fuel combustion) in Bolivia and CO2 emissions (% of total fuel combustion) in Trinidad and Tobago?
Provide a short and direct response. 9.83. In the year 2007, what is the difference between the CO2 emissions (% of total fuel combustion) of Mozambique and CO2 emissions (% of total fuel combustion) of Poland?
Provide a short and direct response. -2.26. In the year 2007, what is the difference between the CO2 emissions (% of total fuel combustion) in Mozambique and CO2 emissions (% of total fuel combustion) in Trinidad and Tobago?
Offer a very short reply. 1.02. In the year 2007, what is the difference between the CO2 emissions (% of total fuel combustion) of Poland and CO2 emissions (% of total fuel combustion) of Trinidad and Tobago?
Keep it short and to the point. 3.28. In the year 2008, what is the difference between the CO2 emissions (% of total fuel combustion) of Bolivia and CO2 emissions (% of total fuel combustion) of Mozambique?
Your answer should be compact. 9.67. In the year 2008, what is the difference between the CO2 emissions (% of total fuel combustion) in Bolivia and CO2 emissions (% of total fuel combustion) in Poland?
Provide a succinct answer. 7.22. In the year 2008, what is the difference between the CO2 emissions (% of total fuel combustion) of Bolivia and CO2 emissions (% of total fuel combustion) of Trinidad and Tobago?
Provide a succinct answer. 10.68. In the year 2008, what is the difference between the CO2 emissions (% of total fuel combustion) of Mozambique and CO2 emissions (% of total fuel combustion) of Poland?
Make the answer very short. -2.45. In the year 2008, what is the difference between the CO2 emissions (% of total fuel combustion) of Mozambique and CO2 emissions (% of total fuel combustion) of Trinidad and Tobago?
Provide a succinct answer. 1.01. In the year 2008, what is the difference between the CO2 emissions (% of total fuel combustion) of Poland and CO2 emissions (% of total fuel combustion) of Trinidad and Tobago?
Provide a succinct answer. 3.46. In the year 2009, what is the difference between the CO2 emissions (% of total fuel combustion) of Bolivia and CO2 emissions (% of total fuel combustion) of Mozambique?
Provide a succinct answer. 8.73. In the year 2009, what is the difference between the CO2 emissions (% of total fuel combustion) of Bolivia and CO2 emissions (% of total fuel combustion) of Poland?
Your answer should be compact. 6.11. In the year 2009, what is the difference between the CO2 emissions (% of total fuel combustion) of Mozambique and CO2 emissions (% of total fuel combustion) of Poland?
Your answer should be compact. -2.62. What is the ratio of the CO2 emissions (% of total fuel combustion) of Bolivia in 1994 to that in 1995?
Your answer should be very brief. 0.9. What is the ratio of the CO2 emissions (% of total fuel combustion) of Mozambique in 1994 to that in 1995?
Provide a short and direct response. 0.76. What is the ratio of the CO2 emissions (% of total fuel combustion) of Poland in 1994 to that in 1995?
Your answer should be very brief. 1.02. What is the ratio of the CO2 emissions (% of total fuel combustion) of Bolivia in 1994 to that in 1996?
Ensure brevity in your answer.  2.12. What is the ratio of the CO2 emissions (% of total fuel combustion) of Mozambique in 1994 to that in 1996?
Make the answer very short. 5.09. What is the ratio of the CO2 emissions (% of total fuel combustion) in Poland in 1994 to that in 1996?
Provide a short and direct response. 1.01. What is the ratio of the CO2 emissions (% of total fuel combustion) of Bolivia in 1994 to that in 1998?
Offer a terse response. 2.28. What is the ratio of the CO2 emissions (% of total fuel combustion) in Mozambique in 1994 to that in 1998?
Make the answer very short. 3.61. What is the ratio of the CO2 emissions (% of total fuel combustion) in Poland in 1994 to that in 1998?
Ensure brevity in your answer.  0.97. What is the ratio of the CO2 emissions (% of total fuel combustion) in Bolivia in 1994 to that in 2006?
Give a very brief answer. 0.06. What is the ratio of the CO2 emissions (% of total fuel combustion) of Mozambique in 1994 to that in 2006?
Your response must be concise. 7.57. What is the ratio of the CO2 emissions (% of total fuel combustion) of Poland in 1994 to that in 2006?
Make the answer very short. 1.15. What is the ratio of the CO2 emissions (% of total fuel combustion) in Bolivia in 1994 to that in 2007?
Your answer should be compact. 0.07. What is the ratio of the CO2 emissions (% of total fuel combustion) in Mozambique in 1994 to that in 2007?
Make the answer very short. 9.21. What is the ratio of the CO2 emissions (% of total fuel combustion) of Poland in 1994 to that in 2007?
Make the answer very short. 1.25. What is the ratio of the CO2 emissions (% of total fuel combustion) in Bolivia in 1994 to that in 2008?
Your answer should be compact. 0.06. What is the ratio of the CO2 emissions (% of total fuel combustion) of Mozambique in 1994 to that in 2008?
Keep it short and to the point. 9.02. What is the ratio of the CO2 emissions (% of total fuel combustion) of Poland in 1994 to that in 2008?
Provide a succinct answer. 1.18. What is the ratio of the CO2 emissions (% of total fuel combustion) in Bolivia in 1994 to that in 2009?
Keep it short and to the point. 0.07. What is the ratio of the CO2 emissions (% of total fuel combustion) of Mozambique in 1994 to that in 2009?
Keep it short and to the point. 10.23. What is the ratio of the CO2 emissions (% of total fuel combustion) of Poland in 1994 to that in 2009?
Keep it short and to the point. 1.16. What is the ratio of the CO2 emissions (% of total fuel combustion) in Bolivia in 1995 to that in 1996?
Give a very brief answer. 2.35. What is the ratio of the CO2 emissions (% of total fuel combustion) in Mozambique in 1995 to that in 1996?
Give a very brief answer. 6.69. What is the ratio of the CO2 emissions (% of total fuel combustion) of Bolivia in 1995 to that in 1998?
Your response must be concise. 2.52. What is the ratio of the CO2 emissions (% of total fuel combustion) in Mozambique in 1995 to that in 1998?
Ensure brevity in your answer.  4.75. What is the ratio of the CO2 emissions (% of total fuel combustion) of Poland in 1995 to that in 1998?
Your answer should be very brief. 0.95. What is the ratio of the CO2 emissions (% of total fuel combustion) of Bolivia in 1995 to that in 2006?
Provide a succinct answer. 0.07. What is the ratio of the CO2 emissions (% of total fuel combustion) of Mozambique in 1995 to that in 2006?
Your response must be concise. 9.95. What is the ratio of the CO2 emissions (% of total fuel combustion) in Poland in 1995 to that in 2006?
Keep it short and to the point. 1.13. What is the ratio of the CO2 emissions (% of total fuel combustion) in Bolivia in 1995 to that in 2007?
Offer a very short reply. 0.07. What is the ratio of the CO2 emissions (% of total fuel combustion) in Mozambique in 1995 to that in 2007?
Keep it short and to the point. 12.1. What is the ratio of the CO2 emissions (% of total fuel combustion) of Poland in 1995 to that in 2007?
Make the answer very short. 1.23. What is the ratio of the CO2 emissions (% of total fuel combustion) of Bolivia in 1995 to that in 2008?
Give a very brief answer. 0.07. What is the ratio of the CO2 emissions (% of total fuel combustion) in Mozambique in 1995 to that in 2008?
Offer a very short reply. 11.85. What is the ratio of the CO2 emissions (% of total fuel combustion) of Poland in 1995 to that in 2008?
Your answer should be very brief. 1.15. What is the ratio of the CO2 emissions (% of total fuel combustion) of Bolivia in 1995 to that in 2009?
Keep it short and to the point. 0.08. What is the ratio of the CO2 emissions (% of total fuel combustion) in Mozambique in 1995 to that in 2009?
Offer a terse response. 13.45. What is the ratio of the CO2 emissions (% of total fuel combustion) in Poland in 1995 to that in 2009?
Your answer should be very brief. 1.13. What is the ratio of the CO2 emissions (% of total fuel combustion) in Bolivia in 1996 to that in 1998?
Provide a succinct answer. 1.07. What is the ratio of the CO2 emissions (% of total fuel combustion) in Mozambique in 1996 to that in 1998?
Offer a terse response. 0.71. What is the ratio of the CO2 emissions (% of total fuel combustion) in Poland in 1996 to that in 1998?
Offer a very short reply. 0.96. What is the ratio of the CO2 emissions (% of total fuel combustion) in Bolivia in 1996 to that in 2006?
Offer a terse response. 0.03. What is the ratio of the CO2 emissions (% of total fuel combustion) of Mozambique in 1996 to that in 2006?
Make the answer very short. 1.49. What is the ratio of the CO2 emissions (% of total fuel combustion) of Poland in 1996 to that in 2006?
Your answer should be very brief. 1.14. What is the ratio of the CO2 emissions (% of total fuel combustion) of Bolivia in 1996 to that in 2007?
Make the answer very short. 0.03. What is the ratio of the CO2 emissions (% of total fuel combustion) of Mozambique in 1996 to that in 2007?
Provide a short and direct response. 1.81. What is the ratio of the CO2 emissions (% of total fuel combustion) of Poland in 1996 to that in 2007?
Your answer should be very brief. 1.24. What is the ratio of the CO2 emissions (% of total fuel combustion) in Bolivia in 1996 to that in 2008?
Your answer should be compact. 0.03. What is the ratio of the CO2 emissions (% of total fuel combustion) in Mozambique in 1996 to that in 2008?
Offer a very short reply. 1.77. What is the ratio of the CO2 emissions (% of total fuel combustion) of Poland in 1996 to that in 2008?
Give a very brief answer. 1.16. What is the ratio of the CO2 emissions (% of total fuel combustion) of Bolivia in 1996 to that in 2009?
Your answer should be very brief. 0.03. What is the ratio of the CO2 emissions (% of total fuel combustion) of Mozambique in 1996 to that in 2009?
Your response must be concise. 2.01. What is the ratio of the CO2 emissions (% of total fuel combustion) of Poland in 1996 to that in 2009?
Offer a very short reply. 1.14. What is the ratio of the CO2 emissions (% of total fuel combustion) of Bolivia in 1998 to that in 2006?
Make the answer very short. 0.03. What is the ratio of the CO2 emissions (% of total fuel combustion) in Mozambique in 1998 to that in 2006?
Provide a succinct answer. 2.09. What is the ratio of the CO2 emissions (% of total fuel combustion) of Poland in 1998 to that in 2006?
Your answer should be compact. 1.19. What is the ratio of the CO2 emissions (% of total fuel combustion) of Bolivia in 1998 to that in 2007?
Offer a terse response. 0.03. What is the ratio of the CO2 emissions (% of total fuel combustion) in Mozambique in 1998 to that in 2007?
Ensure brevity in your answer.  2.55. What is the ratio of the CO2 emissions (% of total fuel combustion) in Poland in 1998 to that in 2007?
Offer a very short reply. 1.29. What is the ratio of the CO2 emissions (% of total fuel combustion) in Bolivia in 1998 to that in 2008?
Your answer should be compact. 0.03. What is the ratio of the CO2 emissions (% of total fuel combustion) in Mozambique in 1998 to that in 2008?
Keep it short and to the point. 2.5. What is the ratio of the CO2 emissions (% of total fuel combustion) in Poland in 1998 to that in 2008?
Your response must be concise. 1.21. What is the ratio of the CO2 emissions (% of total fuel combustion) in Bolivia in 1998 to that in 2009?
Give a very brief answer. 0.03. What is the ratio of the CO2 emissions (% of total fuel combustion) of Mozambique in 1998 to that in 2009?
Keep it short and to the point. 2.83. What is the ratio of the CO2 emissions (% of total fuel combustion) of Poland in 1998 to that in 2009?
Ensure brevity in your answer.  1.19. What is the ratio of the CO2 emissions (% of total fuel combustion) in Bolivia in 2006 to that in 2007?
Your response must be concise. 1.09. What is the ratio of the CO2 emissions (% of total fuel combustion) of Mozambique in 2006 to that in 2007?
Offer a very short reply. 1.22. What is the ratio of the CO2 emissions (% of total fuel combustion) in Poland in 2006 to that in 2007?
Provide a succinct answer. 1.09. What is the ratio of the CO2 emissions (% of total fuel combustion) in Trinidad and Tobago in 2006 to that in 2007?
Give a very brief answer. 1.06. What is the ratio of the CO2 emissions (% of total fuel combustion) in Bolivia in 2006 to that in 2008?
Ensure brevity in your answer.  1. What is the ratio of the CO2 emissions (% of total fuel combustion) of Mozambique in 2006 to that in 2008?
Offer a very short reply. 1.19. What is the ratio of the CO2 emissions (% of total fuel combustion) in Poland in 2006 to that in 2008?
Offer a very short reply. 1.02. What is the ratio of the CO2 emissions (% of total fuel combustion) of Bolivia in 2006 to that in 2009?
Your answer should be compact. 1.11. What is the ratio of the CO2 emissions (% of total fuel combustion) of Mozambique in 2006 to that in 2009?
Your answer should be very brief. 1.35. What is the ratio of the CO2 emissions (% of total fuel combustion) in Poland in 2006 to that in 2009?
Provide a succinct answer. 1.01. What is the ratio of the CO2 emissions (% of total fuel combustion) of Bolivia in 2007 to that in 2008?
Keep it short and to the point. 0.92. What is the ratio of the CO2 emissions (% of total fuel combustion) in Mozambique in 2007 to that in 2008?
Offer a terse response. 0.98. What is the ratio of the CO2 emissions (% of total fuel combustion) of Poland in 2007 to that in 2008?
Keep it short and to the point. 0.94. What is the ratio of the CO2 emissions (% of total fuel combustion) in Trinidad and Tobago in 2007 to that in 2008?
Your response must be concise. 0. What is the ratio of the CO2 emissions (% of total fuel combustion) in Bolivia in 2007 to that in 2009?
Ensure brevity in your answer.  1.02. What is the ratio of the CO2 emissions (% of total fuel combustion) in Mozambique in 2007 to that in 2009?
Offer a very short reply. 1.11. What is the ratio of the CO2 emissions (% of total fuel combustion) in Poland in 2007 to that in 2009?
Keep it short and to the point. 0.93. What is the ratio of the CO2 emissions (% of total fuel combustion) of Bolivia in 2008 to that in 2009?
Your response must be concise. 1.11. What is the ratio of the CO2 emissions (% of total fuel combustion) of Mozambique in 2008 to that in 2009?
Keep it short and to the point. 1.13. What is the ratio of the CO2 emissions (% of total fuel combustion) of Poland in 2008 to that in 2009?
Offer a terse response. 0.99. What is the difference between the highest and the second highest CO2 emissions (% of total fuel combustion) in Bolivia?
Offer a terse response. 0.01. What is the difference between the highest and the second highest CO2 emissions (% of total fuel combustion) in Mozambique?
Your answer should be compact. 2.93. What is the difference between the highest and the second highest CO2 emissions (% of total fuel combustion) in Poland?
Provide a succinct answer. 0.12. What is the difference between the highest and the second highest CO2 emissions (% of total fuel combustion) of Trinidad and Tobago?
Your answer should be compact. 0.03. What is the difference between the highest and the lowest CO2 emissions (% of total fuel combustion) of Bolivia?
Give a very brief answer. 10.43. What is the difference between the highest and the lowest CO2 emissions (% of total fuel combustion) in Mozambique?
Offer a terse response. 11.37. What is the difference between the highest and the lowest CO2 emissions (% of total fuel combustion) of Poland?
Provide a short and direct response. 0.95. What is the difference between the highest and the lowest CO2 emissions (% of total fuel combustion) of Trinidad and Tobago?
Give a very brief answer. 0.03. 